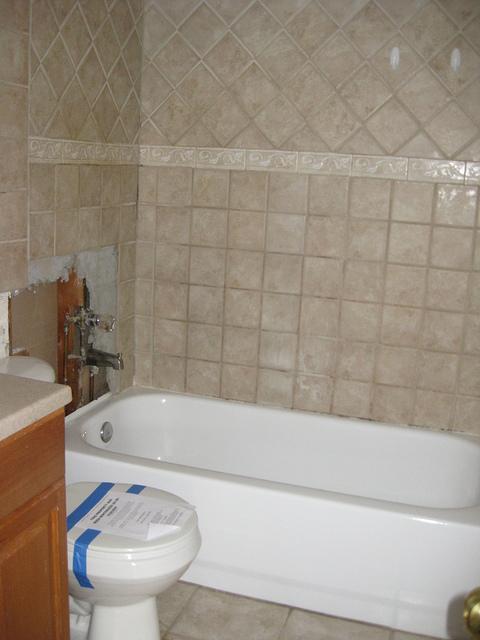How many toilets are there?
Give a very brief answer. 1. How many giraffes are in this scene?
Give a very brief answer. 0. 